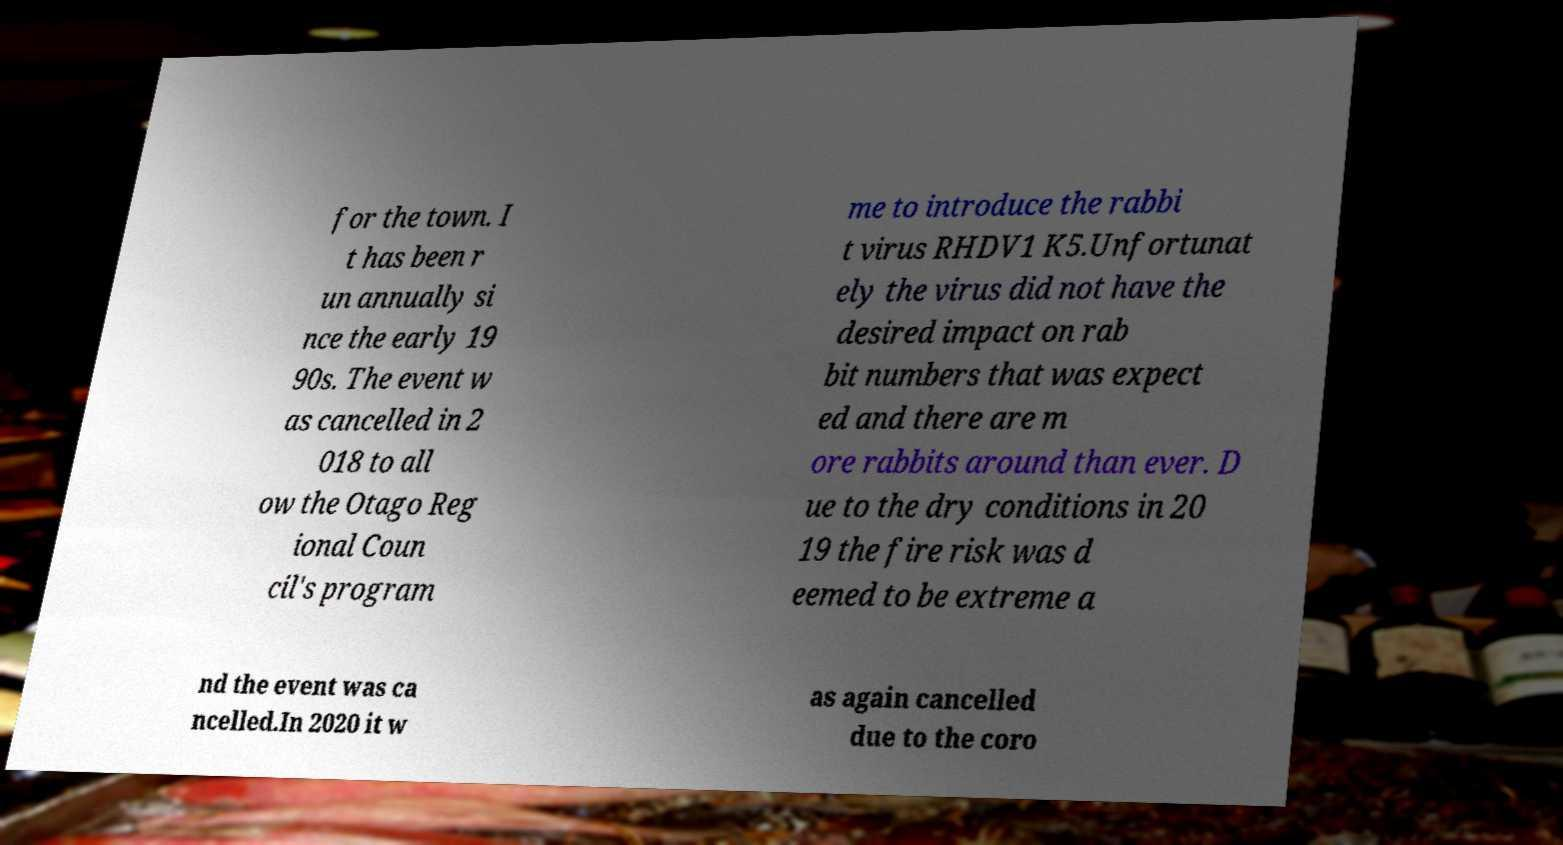For documentation purposes, I need the text within this image transcribed. Could you provide that? for the town. I t has been r un annually si nce the early 19 90s. The event w as cancelled in 2 018 to all ow the Otago Reg ional Coun cil's program me to introduce the rabbi t virus RHDV1 K5.Unfortunat ely the virus did not have the desired impact on rab bit numbers that was expect ed and there are m ore rabbits around than ever. D ue to the dry conditions in 20 19 the fire risk was d eemed to be extreme a nd the event was ca ncelled.In 2020 it w as again cancelled due to the coro 